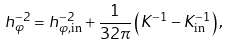<formula> <loc_0><loc_0><loc_500><loc_500>h _ { \varphi } ^ { - 2 } = h ^ { - 2 } _ { \varphi , \text {in} } + \frac { 1 } { 3 2 \pi } \left ( K ^ { - 1 } - K ^ { - 1 } _ { \text {in} } \right ) ,</formula> 